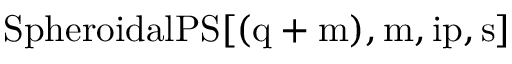<formula> <loc_0><loc_0><loc_500><loc_500>{ S p h e r o i d a l P S } [ ( q + m ) , m , i p , s ]</formula> 